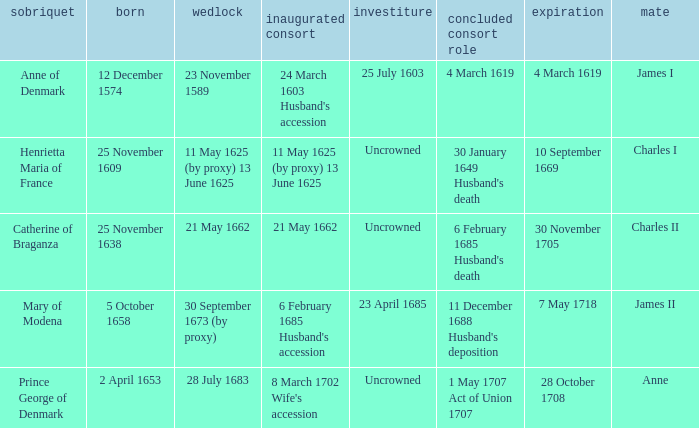Could you parse the entire table as a dict? {'header': ['sobriquet', 'born', 'wedlock', 'inaugurated consort', 'investiture', 'concluded consort role', 'expiration', 'mate'], 'rows': [['Anne of Denmark', '12 December 1574', '23 November 1589', "24 March 1603 Husband's accession", '25 July 1603', '4 March 1619', '4 March 1619', 'James I'], ['Henrietta Maria of France', '25 November 1609', '11 May 1625 (by proxy) 13 June 1625', '11 May 1625 (by proxy) 13 June 1625', 'Uncrowned', "30 January 1649 Husband's death", '10 September 1669', 'Charles I'], ['Catherine of Braganza', '25 November 1638', '21 May 1662', '21 May 1662', 'Uncrowned', "6 February 1685 Husband's death", '30 November 1705', 'Charles II'], ['Mary of Modena', '5 October 1658', '30 September 1673 (by proxy)', "6 February 1685 Husband's accession", '23 April 1685', "11 December 1688 Husband's deposition", '7 May 1718', 'James II'], ['Prince George of Denmark', '2 April 1653', '28 July 1683', "8 March 1702 Wife's accession", 'Uncrowned', '1 May 1707 Act of Union 1707', '28 October 1708', 'Anne']]} When was the date of death for the person married to Charles II? 30 November 1705. 